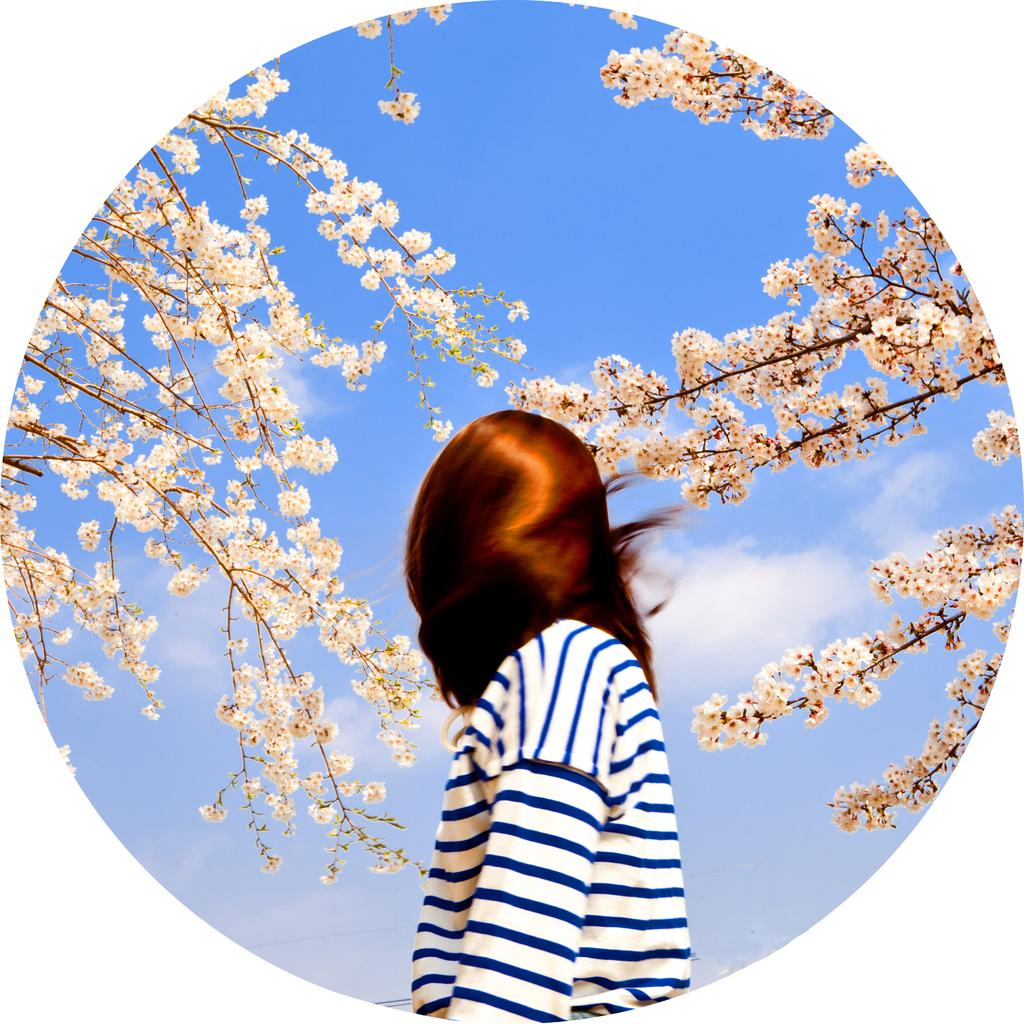What is the main subject of the image? There is a person in the image. What type of vegetation can be seen in the image? There are branches of trees with flowers in the image. What can be seen in the background of the image? Sky is visible in the background of the image. What is the condition of the sky in the image? Clouds are present in the sky. What type of marble is being used to build the owl's nest in the image? There is no owl or nest present in the image, and therefore no marble can be associated with it. 